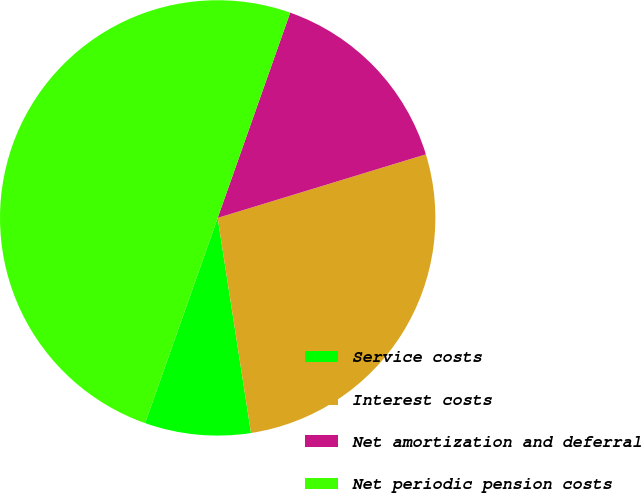Convert chart to OTSL. <chart><loc_0><loc_0><loc_500><loc_500><pie_chart><fcel>Service costs<fcel>Interest costs<fcel>Net amortization and deferral<fcel>Net periodic pension costs<nl><fcel>7.86%<fcel>27.27%<fcel>14.88%<fcel>50.0%<nl></chart> 